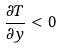Convert formula to latex. <formula><loc_0><loc_0><loc_500><loc_500>\frac { \partial T } { \partial y } < 0</formula> 